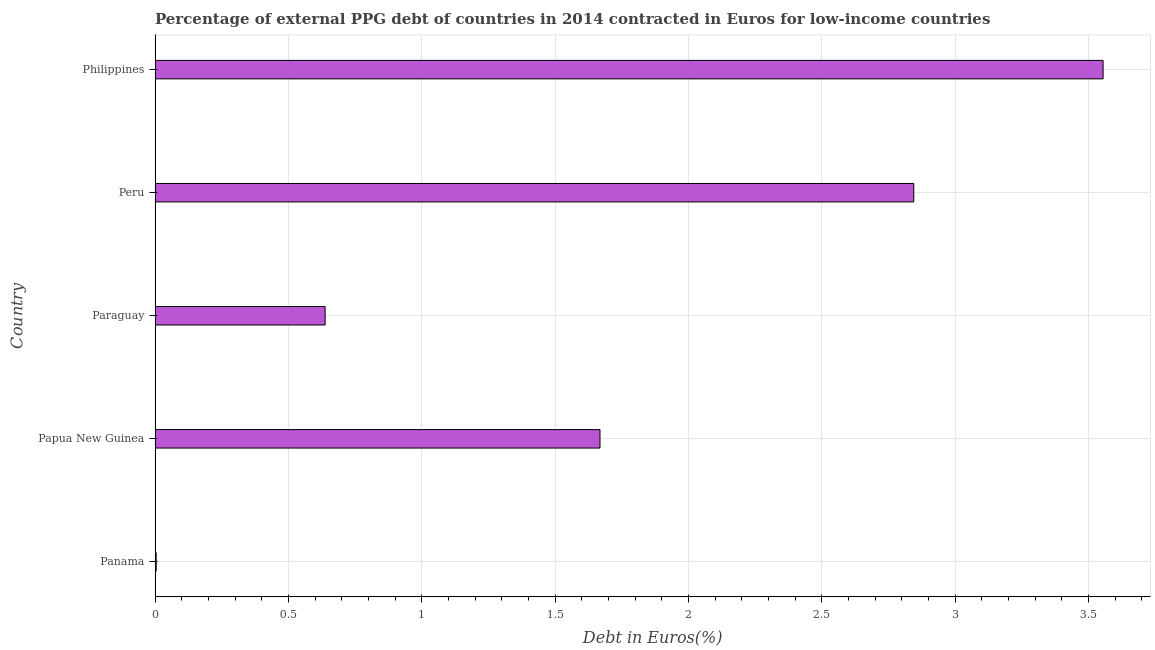Does the graph contain any zero values?
Provide a short and direct response. No. What is the title of the graph?
Give a very brief answer. Percentage of external PPG debt of countries in 2014 contracted in Euros for low-income countries. What is the label or title of the X-axis?
Ensure brevity in your answer.  Debt in Euros(%). What is the label or title of the Y-axis?
Your answer should be compact. Country. What is the currency composition of ppg debt in Panama?
Provide a succinct answer. 0. Across all countries, what is the maximum currency composition of ppg debt?
Offer a terse response. 3.56. Across all countries, what is the minimum currency composition of ppg debt?
Provide a short and direct response. 0. In which country was the currency composition of ppg debt minimum?
Make the answer very short. Panama. What is the sum of the currency composition of ppg debt?
Provide a short and direct response. 8.71. What is the difference between the currency composition of ppg debt in Peru and Philippines?
Give a very brief answer. -0.71. What is the average currency composition of ppg debt per country?
Offer a terse response. 1.74. What is the median currency composition of ppg debt?
Keep it short and to the point. 1.67. In how many countries, is the currency composition of ppg debt greater than 2.3 %?
Provide a short and direct response. 2. What is the ratio of the currency composition of ppg debt in Panama to that in Papua New Guinea?
Your response must be concise. 0. Is the currency composition of ppg debt in Papua New Guinea less than that in Paraguay?
Give a very brief answer. No. Is the difference between the currency composition of ppg debt in Panama and Philippines greater than the difference between any two countries?
Ensure brevity in your answer.  Yes. What is the difference between the highest and the second highest currency composition of ppg debt?
Give a very brief answer. 0.71. What is the difference between the highest and the lowest currency composition of ppg debt?
Provide a succinct answer. 3.55. In how many countries, is the currency composition of ppg debt greater than the average currency composition of ppg debt taken over all countries?
Your response must be concise. 2. How many bars are there?
Offer a very short reply. 5. Are all the bars in the graph horizontal?
Your response must be concise. Yes. What is the difference between two consecutive major ticks on the X-axis?
Give a very brief answer. 0.5. Are the values on the major ticks of X-axis written in scientific E-notation?
Your answer should be compact. No. What is the Debt in Euros(%) of Panama?
Ensure brevity in your answer.  0. What is the Debt in Euros(%) in Papua New Guinea?
Provide a short and direct response. 1.67. What is the Debt in Euros(%) in Paraguay?
Offer a terse response. 0.64. What is the Debt in Euros(%) in Peru?
Your answer should be compact. 2.85. What is the Debt in Euros(%) of Philippines?
Keep it short and to the point. 3.56. What is the difference between the Debt in Euros(%) in Panama and Papua New Guinea?
Offer a terse response. -1.66. What is the difference between the Debt in Euros(%) in Panama and Paraguay?
Your answer should be very brief. -0.63. What is the difference between the Debt in Euros(%) in Panama and Peru?
Offer a very short reply. -2.84. What is the difference between the Debt in Euros(%) in Panama and Philippines?
Provide a short and direct response. -3.55. What is the difference between the Debt in Euros(%) in Papua New Guinea and Paraguay?
Keep it short and to the point. 1.03. What is the difference between the Debt in Euros(%) in Papua New Guinea and Peru?
Your response must be concise. -1.18. What is the difference between the Debt in Euros(%) in Papua New Guinea and Philippines?
Keep it short and to the point. -1.89. What is the difference between the Debt in Euros(%) in Paraguay and Peru?
Provide a succinct answer. -2.21. What is the difference between the Debt in Euros(%) in Paraguay and Philippines?
Your answer should be very brief. -2.92. What is the difference between the Debt in Euros(%) in Peru and Philippines?
Offer a very short reply. -0.71. What is the ratio of the Debt in Euros(%) in Panama to that in Papua New Guinea?
Your answer should be compact. 0. What is the ratio of the Debt in Euros(%) in Panama to that in Paraguay?
Give a very brief answer. 0.01. What is the ratio of the Debt in Euros(%) in Panama to that in Peru?
Your answer should be compact. 0. What is the ratio of the Debt in Euros(%) in Papua New Guinea to that in Paraguay?
Your response must be concise. 2.62. What is the ratio of the Debt in Euros(%) in Papua New Guinea to that in Peru?
Provide a short and direct response. 0.59. What is the ratio of the Debt in Euros(%) in Papua New Guinea to that in Philippines?
Your answer should be compact. 0.47. What is the ratio of the Debt in Euros(%) in Paraguay to that in Peru?
Your answer should be compact. 0.22. What is the ratio of the Debt in Euros(%) in Paraguay to that in Philippines?
Make the answer very short. 0.18. What is the ratio of the Debt in Euros(%) in Peru to that in Philippines?
Keep it short and to the point. 0.8. 